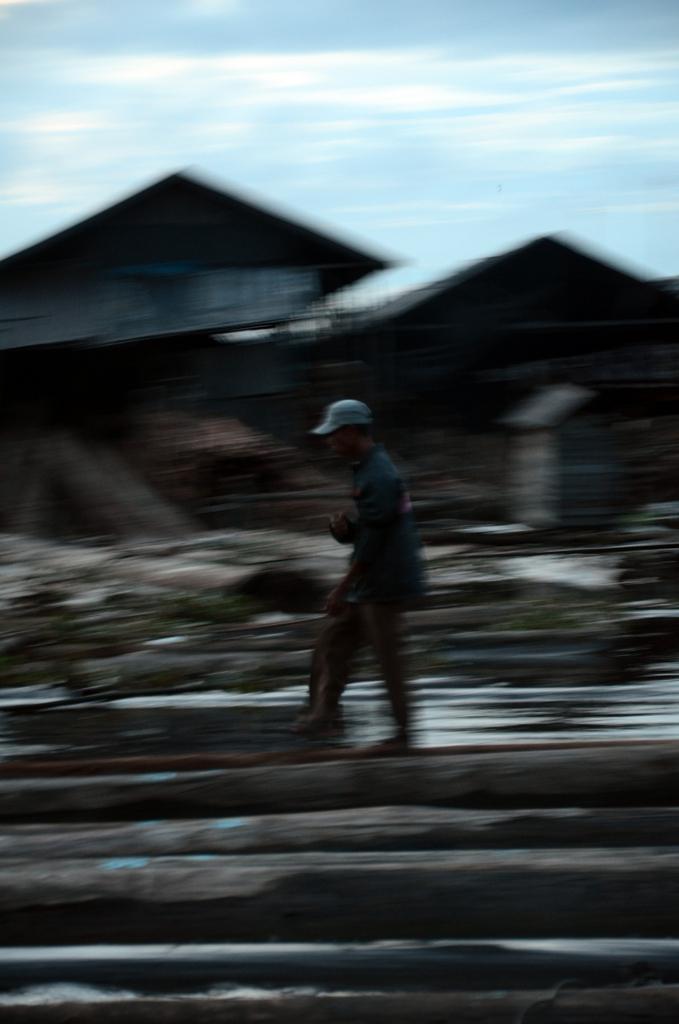Could you give a brief overview of what you see in this image? In this image person is walking on the wooden log. At the back side there are buildings and sky. 